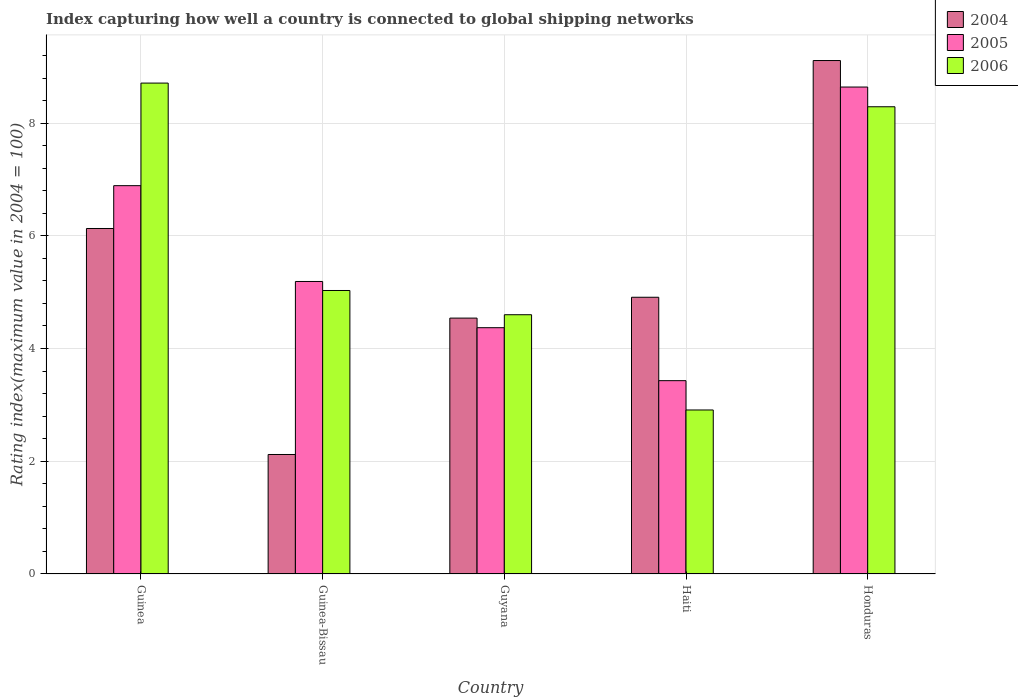How many different coloured bars are there?
Your response must be concise. 3. Are the number of bars on each tick of the X-axis equal?
Your answer should be very brief. Yes. How many bars are there on the 4th tick from the right?
Offer a terse response. 3. What is the label of the 2nd group of bars from the left?
Your response must be concise. Guinea-Bissau. What is the rating index in 2005 in Guinea-Bissau?
Your response must be concise. 5.19. Across all countries, what is the maximum rating index in 2004?
Your answer should be very brief. 9.11. Across all countries, what is the minimum rating index in 2004?
Your response must be concise. 2.12. In which country was the rating index in 2006 maximum?
Provide a short and direct response. Guinea. In which country was the rating index in 2006 minimum?
Offer a very short reply. Haiti. What is the total rating index in 2004 in the graph?
Your answer should be very brief. 26.81. What is the difference between the rating index in 2004 in Guinea-Bissau and that in Haiti?
Give a very brief answer. -2.79. What is the difference between the rating index in 2004 in Guinea-Bissau and the rating index in 2005 in Honduras?
Provide a succinct answer. -6.52. What is the average rating index in 2005 per country?
Ensure brevity in your answer.  5.7. What is the difference between the rating index of/in 2006 and rating index of/in 2004 in Guinea?
Offer a very short reply. 2.58. What is the ratio of the rating index in 2005 in Guinea-Bissau to that in Honduras?
Offer a very short reply. 0.6. Is the difference between the rating index in 2006 in Guinea and Guyana greater than the difference between the rating index in 2004 in Guinea and Guyana?
Give a very brief answer. Yes. What is the difference between the highest and the second highest rating index in 2005?
Your answer should be very brief. 3.45. What is the difference between the highest and the lowest rating index in 2006?
Keep it short and to the point. 5.8. What does the 1st bar from the left in Honduras represents?
Give a very brief answer. 2004. Is it the case that in every country, the sum of the rating index in 2006 and rating index in 2004 is greater than the rating index in 2005?
Ensure brevity in your answer.  Yes. Are all the bars in the graph horizontal?
Provide a short and direct response. No. How many countries are there in the graph?
Ensure brevity in your answer.  5. Does the graph contain grids?
Offer a terse response. Yes. Where does the legend appear in the graph?
Provide a short and direct response. Top right. How many legend labels are there?
Offer a terse response. 3. How are the legend labels stacked?
Your answer should be compact. Vertical. What is the title of the graph?
Your answer should be very brief. Index capturing how well a country is connected to global shipping networks. What is the label or title of the Y-axis?
Offer a terse response. Rating index(maximum value in 2004 = 100). What is the Rating index(maximum value in 2004 = 100) of 2004 in Guinea?
Your response must be concise. 6.13. What is the Rating index(maximum value in 2004 = 100) of 2005 in Guinea?
Your answer should be very brief. 6.89. What is the Rating index(maximum value in 2004 = 100) in 2006 in Guinea?
Your response must be concise. 8.71. What is the Rating index(maximum value in 2004 = 100) in 2004 in Guinea-Bissau?
Your answer should be compact. 2.12. What is the Rating index(maximum value in 2004 = 100) in 2005 in Guinea-Bissau?
Make the answer very short. 5.19. What is the Rating index(maximum value in 2004 = 100) of 2006 in Guinea-Bissau?
Provide a succinct answer. 5.03. What is the Rating index(maximum value in 2004 = 100) of 2004 in Guyana?
Give a very brief answer. 4.54. What is the Rating index(maximum value in 2004 = 100) of 2005 in Guyana?
Offer a very short reply. 4.37. What is the Rating index(maximum value in 2004 = 100) of 2004 in Haiti?
Offer a very short reply. 4.91. What is the Rating index(maximum value in 2004 = 100) in 2005 in Haiti?
Provide a succinct answer. 3.43. What is the Rating index(maximum value in 2004 = 100) of 2006 in Haiti?
Offer a very short reply. 2.91. What is the Rating index(maximum value in 2004 = 100) of 2004 in Honduras?
Offer a very short reply. 9.11. What is the Rating index(maximum value in 2004 = 100) of 2005 in Honduras?
Offer a very short reply. 8.64. What is the Rating index(maximum value in 2004 = 100) in 2006 in Honduras?
Give a very brief answer. 8.29. Across all countries, what is the maximum Rating index(maximum value in 2004 = 100) of 2004?
Your response must be concise. 9.11. Across all countries, what is the maximum Rating index(maximum value in 2004 = 100) of 2005?
Keep it short and to the point. 8.64. Across all countries, what is the maximum Rating index(maximum value in 2004 = 100) in 2006?
Your answer should be very brief. 8.71. Across all countries, what is the minimum Rating index(maximum value in 2004 = 100) of 2004?
Keep it short and to the point. 2.12. Across all countries, what is the minimum Rating index(maximum value in 2004 = 100) in 2005?
Offer a terse response. 3.43. Across all countries, what is the minimum Rating index(maximum value in 2004 = 100) in 2006?
Provide a succinct answer. 2.91. What is the total Rating index(maximum value in 2004 = 100) of 2004 in the graph?
Ensure brevity in your answer.  26.81. What is the total Rating index(maximum value in 2004 = 100) in 2005 in the graph?
Make the answer very short. 28.52. What is the total Rating index(maximum value in 2004 = 100) of 2006 in the graph?
Provide a short and direct response. 29.54. What is the difference between the Rating index(maximum value in 2004 = 100) in 2004 in Guinea and that in Guinea-Bissau?
Offer a terse response. 4.01. What is the difference between the Rating index(maximum value in 2004 = 100) of 2005 in Guinea and that in Guinea-Bissau?
Ensure brevity in your answer.  1.7. What is the difference between the Rating index(maximum value in 2004 = 100) of 2006 in Guinea and that in Guinea-Bissau?
Ensure brevity in your answer.  3.68. What is the difference between the Rating index(maximum value in 2004 = 100) of 2004 in Guinea and that in Guyana?
Your answer should be compact. 1.59. What is the difference between the Rating index(maximum value in 2004 = 100) of 2005 in Guinea and that in Guyana?
Give a very brief answer. 2.52. What is the difference between the Rating index(maximum value in 2004 = 100) in 2006 in Guinea and that in Guyana?
Provide a short and direct response. 4.11. What is the difference between the Rating index(maximum value in 2004 = 100) in 2004 in Guinea and that in Haiti?
Your answer should be compact. 1.22. What is the difference between the Rating index(maximum value in 2004 = 100) of 2005 in Guinea and that in Haiti?
Ensure brevity in your answer.  3.46. What is the difference between the Rating index(maximum value in 2004 = 100) in 2006 in Guinea and that in Haiti?
Provide a succinct answer. 5.8. What is the difference between the Rating index(maximum value in 2004 = 100) in 2004 in Guinea and that in Honduras?
Offer a very short reply. -2.98. What is the difference between the Rating index(maximum value in 2004 = 100) in 2005 in Guinea and that in Honduras?
Provide a succinct answer. -1.75. What is the difference between the Rating index(maximum value in 2004 = 100) in 2006 in Guinea and that in Honduras?
Make the answer very short. 0.42. What is the difference between the Rating index(maximum value in 2004 = 100) of 2004 in Guinea-Bissau and that in Guyana?
Make the answer very short. -2.42. What is the difference between the Rating index(maximum value in 2004 = 100) of 2005 in Guinea-Bissau and that in Guyana?
Give a very brief answer. 0.82. What is the difference between the Rating index(maximum value in 2004 = 100) in 2006 in Guinea-Bissau and that in Guyana?
Give a very brief answer. 0.43. What is the difference between the Rating index(maximum value in 2004 = 100) in 2004 in Guinea-Bissau and that in Haiti?
Provide a short and direct response. -2.79. What is the difference between the Rating index(maximum value in 2004 = 100) in 2005 in Guinea-Bissau and that in Haiti?
Ensure brevity in your answer.  1.76. What is the difference between the Rating index(maximum value in 2004 = 100) of 2006 in Guinea-Bissau and that in Haiti?
Offer a terse response. 2.12. What is the difference between the Rating index(maximum value in 2004 = 100) of 2004 in Guinea-Bissau and that in Honduras?
Keep it short and to the point. -6.99. What is the difference between the Rating index(maximum value in 2004 = 100) in 2005 in Guinea-Bissau and that in Honduras?
Provide a succinct answer. -3.45. What is the difference between the Rating index(maximum value in 2004 = 100) in 2006 in Guinea-Bissau and that in Honduras?
Provide a succinct answer. -3.26. What is the difference between the Rating index(maximum value in 2004 = 100) of 2004 in Guyana and that in Haiti?
Provide a succinct answer. -0.37. What is the difference between the Rating index(maximum value in 2004 = 100) of 2006 in Guyana and that in Haiti?
Provide a short and direct response. 1.69. What is the difference between the Rating index(maximum value in 2004 = 100) of 2004 in Guyana and that in Honduras?
Your answer should be very brief. -4.57. What is the difference between the Rating index(maximum value in 2004 = 100) in 2005 in Guyana and that in Honduras?
Make the answer very short. -4.27. What is the difference between the Rating index(maximum value in 2004 = 100) of 2006 in Guyana and that in Honduras?
Your response must be concise. -3.69. What is the difference between the Rating index(maximum value in 2004 = 100) in 2005 in Haiti and that in Honduras?
Give a very brief answer. -5.21. What is the difference between the Rating index(maximum value in 2004 = 100) in 2006 in Haiti and that in Honduras?
Ensure brevity in your answer.  -5.38. What is the difference between the Rating index(maximum value in 2004 = 100) in 2005 in Guinea and the Rating index(maximum value in 2004 = 100) in 2006 in Guinea-Bissau?
Provide a short and direct response. 1.86. What is the difference between the Rating index(maximum value in 2004 = 100) of 2004 in Guinea and the Rating index(maximum value in 2004 = 100) of 2005 in Guyana?
Your response must be concise. 1.76. What is the difference between the Rating index(maximum value in 2004 = 100) in 2004 in Guinea and the Rating index(maximum value in 2004 = 100) in 2006 in Guyana?
Keep it short and to the point. 1.53. What is the difference between the Rating index(maximum value in 2004 = 100) of 2005 in Guinea and the Rating index(maximum value in 2004 = 100) of 2006 in Guyana?
Give a very brief answer. 2.29. What is the difference between the Rating index(maximum value in 2004 = 100) of 2004 in Guinea and the Rating index(maximum value in 2004 = 100) of 2006 in Haiti?
Your response must be concise. 3.22. What is the difference between the Rating index(maximum value in 2004 = 100) of 2005 in Guinea and the Rating index(maximum value in 2004 = 100) of 2006 in Haiti?
Your answer should be very brief. 3.98. What is the difference between the Rating index(maximum value in 2004 = 100) of 2004 in Guinea and the Rating index(maximum value in 2004 = 100) of 2005 in Honduras?
Your answer should be very brief. -2.51. What is the difference between the Rating index(maximum value in 2004 = 100) of 2004 in Guinea and the Rating index(maximum value in 2004 = 100) of 2006 in Honduras?
Offer a very short reply. -2.16. What is the difference between the Rating index(maximum value in 2004 = 100) in 2005 in Guinea and the Rating index(maximum value in 2004 = 100) in 2006 in Honduras?
Keep it short and to the point. -1.4. What is the difference between the Rating index(maximum value in 2004 = 100) in 2004 in Guinea-Bissau and the Rating index(maximum value in 2004 = 100) in 2005 in Guyana?
Ensure brevity in your answer.  -2.25. What is the difference between the Rating index(maximum value in 2004 = 100) in 2004 in Guinea-Bissau and the Rating index(maximum value in 2004 = 100) in 2006 in Guyana?
Your answer should be very brief. -2.48. What is the difference between the Rating index(maximum value in 2004 = 100) of 2005 in Guinea-Bissau and the Rating index(maximum value in 2004 = 100) of 2006 in Guyana?
Keep it short and to the point. 0.59. What is the difference between the Rating index(maximum value in 2004 = 100) in 2004 in Guinea-Bissau and the Rating index(maximum value in 2004 = 100) in 2005 in Haiti?
Your answer should be compact. -1.31. What is the difference between the Rating index(maximum value in 2004 = 100) of 2004 in Guinea-Bissau and the Rating index(maximum value in 2004 = 100) of 2006 in Haiti?
Give a very brief answer. -0.79. What is the difference between the Rating index(maximum value in 2004 = 100) of 2005 in Guinea-Bissau and the Rating index(maximum value in 2004 = 100) of 2006 in Haiti?
Your answer should be compact. 2.28. What is the difference between the Rating index(maximum value in 2004 = 100) in 2004 in Guinea-Bissau and the Rating index(maximum value in 2004 = 100) in 2005 in Honduras?
Your response must be concise. -6.52. What is the difference between the Rating index(maximum value in 2004 = 100) of 2004 in Guinea-Bissau and the Rating index(maximum value in 2004 = 100) of 2006 in Honduras?
Your answer should be very brief. -6.17. What is the difference between the Rating index(maximum value in 2004 = 100) of 2004 in Guyana and the Rating index(maximum value in 2004 = 100) of 2005 in Haiti?
Make the answer very short. 1.11. What is the difference between the Rating index(maximum value in 2004 = 100) of 2004 in Guyana and the Rating index(maximum value in 2004 = 100) of 2006 in Haiti?
Your answer should be compact. 1.63. What is the difference between the Rating index(maximum value in 2004 = 100) in 2005 in Guyana and the Rating index(maximum value in 2004 = 100) in 2006 in Haiti?
Your answer should be compact. 1.46. What is the difference between the Rating index(maximum value in 2004 = 100) of 2004 in Guyana and the Rating index(maximum value in 2004 = 100) of 2005 in Honduras?
Keep it short and to the point. -4.1. What is the difference between the Rating index(maximum value in 2004 = 100) in 2004 in Guyana and the Rating index(maximum value in 2004 = 100) in 2006 in Honduras?
Give a very brief answer. -3.75. What is the difference between the Rating index(maximum value in 2004 = 100) of 2005 in Guyana and the Rating index(maximum value in 2004 = 100) of 2006 in Honduras?
Make the answer very short. -3.92. What is the difference between the Rating index(maximum value in 2004 = 100) in 2004 in Haiti and the Rating index(maximum value in 2004 = 100) in 2005 in Honduras?
Offer a terse response. -3.73. What is the difference between the Rating index(maximum value in 2004 = 100) of 2004 in Haiti and the Rating index(maximum value in 2004 = 100) of 2006 in Honduras?
Give a very brief answer. -3.38. What is the difference between the Rating index(maximum value in 2004 = 100) in 2005 in Haiti and the Rating index(maximum value in 2004 = 100) in 2006 in Honduras?
Offer a very short reply. -4.86. What is the average Rating index(maximum value in 2004 = 100) in 2004 per country?
Offer a very short reply. 5.36. What is the average Rating index(maximum value in 2004 = 100) of 2005 per country?
Give a very brief answer. 5.7. What is the average Rating index(maximum value in 2004 = 100) in 2006 per country?
Provide a succinct answer. 5.91. What is the difference between the Rating index(maximum value in 2004 = 100) in 2004 and Rating index(maximum value in 2004 = 100) in 2005 in Guinea?
Keep it short and to the point. -0.76. What is the difference between the Rating index(maximum value in 2004 = 100) of 2004 and Rating index(maximum value in 2004 = 100) of 2006 in Guinea?
Offer a terse response. -2.58. What is the difference between the Rating index(maximum value in 2004 = 100) in 2005 and Rating index(maximum value in 2004 = 100) in 2006 in Guinea?
Provide a succinct answer. -1.82. What is the difference between the Rating index(maximum value in 2004 = 100) of 2004 and Rating index(maximum value in 2004 = 100) of 2005 in Guinea-Bissau?
Give a very brief answer. -3.07. What is the difference between the Rating index(maximum value in 2004 = 100) in 2004 and Rating index(maximum value in 2004 = 100) in 2006 in Guinea-Bissau?
Ensure brevity in your answer.  -2.91. What is the difference between the Rating index(maximum value in 2004 = 100) in 2005 and Rating index(maximum value in 2004 = 100) in 2006 in Guinea-Bissau?
Give a very brief answer. 0.16. What is the difference between the Rating index(maximum value in 2004 = 100) in 2004 and Rating index(maximum value in 2004 = 100) in 2005 in Guyana?
Give a very brief answer. 0.17. What is the difference between the Rating index(maximum value in 2004 = 100) in 2004 and Rating index(maximum value in 2004 = 100) in 2006 in Guyana?
Provide a succinct answer. -0.06. What is the difference between the Rating index(maximum value in 2004 = 100) of 2005 and Rating index(maximum value in 2004 = 100) of 2006 in Guyana?
Your response must be concise. -0.23. What is the difference between the Rating index(maximum value in 2004 = 100) in 2004 and Rating index(maximum value in 2004 = 100) in 2005 in Haiti?
Keep it short and to the point. 1.48. What is the difference between the Rating index(maximum value in 2004 = 100) in 2004 and Rating index(maximum value in 2004 = 100) in 2006 in Haiti?
Keep it short and to the point. 2. What is the difference between the Rating index(maximum value in 2004 = 100) in 2005 and Rating index(maximum value in 2004 = 100) in 2006 in Haiti?
Ensure brevity in your answer.  0.52. What is the difference between the Rating index(maximum value in 2004 = 100) of 2004 and Rating index(maximum value in 2004 = 100) of 2005 in Honduras?
Your answer should be compact. 0.47. What is the difference between the Rating index(maximum value in 2004 = 100) in 2004 and Rating index(maximum value in 2004 = 100) in 2006 in Honduras?
Provide a succinct answer. 0.82. What is the difference between the Rating index(maximum value in 2004 = 100) in 2005 and Rating index(maximum value in 2004 = 100) in 2006 in Honduras?
Your response must be concise. 0.35. What is the ratio of the Rating index(maximum value in 2004 = 100) of 2004 in Guinea to that in Guinea-Bissau?
Your answer should be compact. 2.89. What is the ratio of the Rating index(maximum value in 2004 = 100) of 2005 in Guinea to that in Guinea-Bissau?
Make the answer very short. 1.33. What is the ratio of the Rating index(maximum value in 2004 = 100) in 2006 in Guinea to that in Guinea-Bissau?
Your response must be concise. 1.73. What is the ratio of the Rating index(maximum value in 2004 = 100) in 2004 in Guinea to that in Guyana?
Your response must be concise. 1.35. What is the ratio of the Rating index(maximum value in 2004 = 100) in 2005 in Guinea to that in Guyana?
Your answer should be compact. 1.58. What is the ratio of the Rating index(maximum value in 2004 = 100) in 2006 in Guinea to that in Guyana?
Offer a terse response. 1.89. What is the ratio of the Rating index(maximum value in 2004 = 100) in 2004 in Guinea to that in Haiti?
Offer a very short reply. 1.25. What is the ratio of the Rating index(maximum value in 2004 = 100) in 2005 in Guinea to that in Haiti?
Offer a terse response. 2.01. What is the ratio of the Rating index(maximum value in 2004 = 100) of 2006 in Guinea to that in Haiti?
Your answer should be compact. 2.99. What is the ratio of the Rating index(maximum value in 2004 = 100) in 2004 in Guinea to that in Honduras?
Keep it short and to the point. 0.67. What is the ratio of the Rating index(maximum value in 2004 = 100) of 2005 in Guinea to that in Honduras?
Your answer should be very brief. 0.8. What is the ratio of the Rating index(maximum value in 2004 = 100) of 2006 in Guinea to that in Honduras?
Offer a very short reply. 1.05. What is the ratio of the Rating index(maximum value in 2004 = 100) in 2004 in Guinea-Bissau to that in Guyana?
Provide a succinct answer. 0.47. What is the ratio of the Rating index(maximum value in 2004 = 100) in 2005 in Guinea-Bissau to that in Guyana?
Offer a very short reply. 1.19. What is the ratio of the Rating index(maximum value in 2004 = 100) of 2006 in Guinea-Bissau to that in Guyana?
Offer a very short reply. 1.09. What is the ratio of the Rating index(maximum value in 2004 = 100) in 2004 in Guinea-Bissau to that in Haiti?
Your answer should be very brief. 0.43. What is the ratio of the Rating index(maximum value in 2004 = 100) of 2005 in Guinea-Bissau to that in Haiti?
Make the answer very short. 1.51. What is the ratio of the Rating index(maximum value in 2004 = 100) in 2006 in Guinea-Bissau to that in Haiti?
Your answer should be compact. 1.73. What is the ratio of the Rating index(maximum value in 2004 = 100) in 2004 in Guinea-Bissau to that in Honduras?
Offer a terse response. 0.23. What is the ratio of the Rating index(maximum value in 2004 = 100) of 2005 in Guinea-Bissau to that in Honduras?
Your response must be concise. 0.6. What is the ratio of the Rating index(maximum value in 2004 = 100) in 2006 in Guinea-Bissau to that in Honduras?
Your response must be concise. 0.61. What is the ratio of the Rating index(maximum value in 2004 = 100) of 2004 in Guyana to that in Haiti?
Your answer should be very brief. 0.92. What is the ratio of the Rating index(maximum value in 2004 = 100) in 2005 in Guyana to that in Haiti?
Offer a very short reply. 1.27. What is the ratio of the Rating index(maximum value in 2004 = 100) in 2006 in Guyana to that in Haiti?
Keep it short and to the point. 1.58. What is the ratio of the Rating index(maximum value in 2004 = 100) of 2004 in Guyana to that in Honduras?
Keep it short and to the point. 0.5. What is the ratio of the Rating index(maximum value in 2004 = 100) in 2005 in Guyana to that in Honduras?
Make the answer very short. 0.51. What is the ratio of the Rating index(maximum value in 2004 = 100) in 2006 in Guyana to that in Honduras?
Your answer should be compact. 0.55. What is the ratio of the Rating index(maximum value in 2004 = 100) in 2004 in Haiti to that in Honduras?
Your response must be concise. 0.54. What is the ratio of the Rating index(maximum value in 2004 = 100) of 2005 in Haiti to that in Honduras?
Give a very brief answer. 0.4. What is the ratio of the Rating index(maximum value in 2004 = 100) in 2006 in Haiti to that in Honduras?
Your answer should be very brief. 0.35. What is the difference between the highest and the second highest Rating index(maximum value in 2004 = 100) of 2004?
Provide a short and direct response. 2.98. What is the difference between the highest and the second highest Rating index(maximum value in 2004 = 100) in 2006?
Provide a succinct answer. 0.42. What is the difference between the highest and the lowest Rating index(maximum value in 2004 = 100) of 2004?
Give a very brief answer. 6.99. What is the difference between the highest and the lowest Rating index(maximum value in 2004 = 100) of 2005?
Your answer should be compact. 5.21. What is the difference between the highest and the lowest Rating index(maximum value in 2004 = 100) in 2006?
Offer a very short reply. 5.8. 